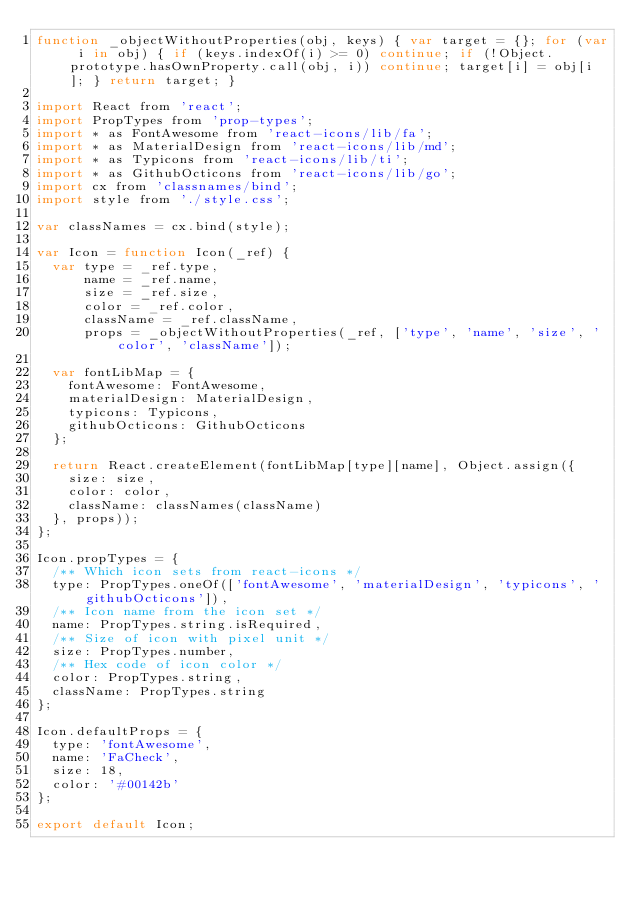<code> <loc_0><loc_0><loc_500><loc_500><_JavaScript_>function _objectWithoutProperties(obj, keys) { var target = {}; for (var i in obj) { if (keys.indexOf(i) >= 0) continue; if (!Object.prototype.hasOwnProperty.call(obj, i)) continue; target[i] = obj[i]; } return target; }

import React from 'react';
import PropTypes from 'prop-types';
import * as FontAwesome from 'react-icons/lib/fa';
import * as MaterialDesign from 'react-icons/lib/md';
import * as Typicons from 'react-icons/lib/ti';
import * as GithubOcticons from 'react-icons/lib/go';
import cx from 'classnames/bind';
import style from './style.css';

var classNames = cx.bind(style);

var Icon = function Icon(_ref) {
  var type = _ref.type,
      name = _ref.name,
      size = _ref.size,
      color = _ref.color,
      className = _ref.className,
      props = _objectWithoutProperties(_ref, ['type', 'name', 'size', 'color', 'className']);

  var fontLibMap = {
    fontAwesome: FontAwesome,
    materialDesign: MaterialDesign,
    typicons: Typicons,
    githubOcticons: GithubOcticons
  };

  return React.createElement(fontLibMap[type][name], Object.assign({
    size: size,
    color: color,
    className: classNames(className)
  }, props));
};

Icon.propTypes = {
  /** Which icon sets from react-icons */
  type: PropTypes.oneOf(['fontAwesome', 'materialDesign', 'typicons', 'githubOcticons']),
  /** Icon name from the icon set */
  name: PropTypes.string.isRequired,
  /** Size of icon with pixel unit */
  size: PropTypes.number,
  /** Hex code of icon color */
  color: PropTypes.string,
  className: PropTypes.string
};

Icon.defaultProps = {
  type: 'fontAwesome',
  name: 'FaCheck',
  size: 18,
  color: '#00142b'
};

export default Icon;</code> 